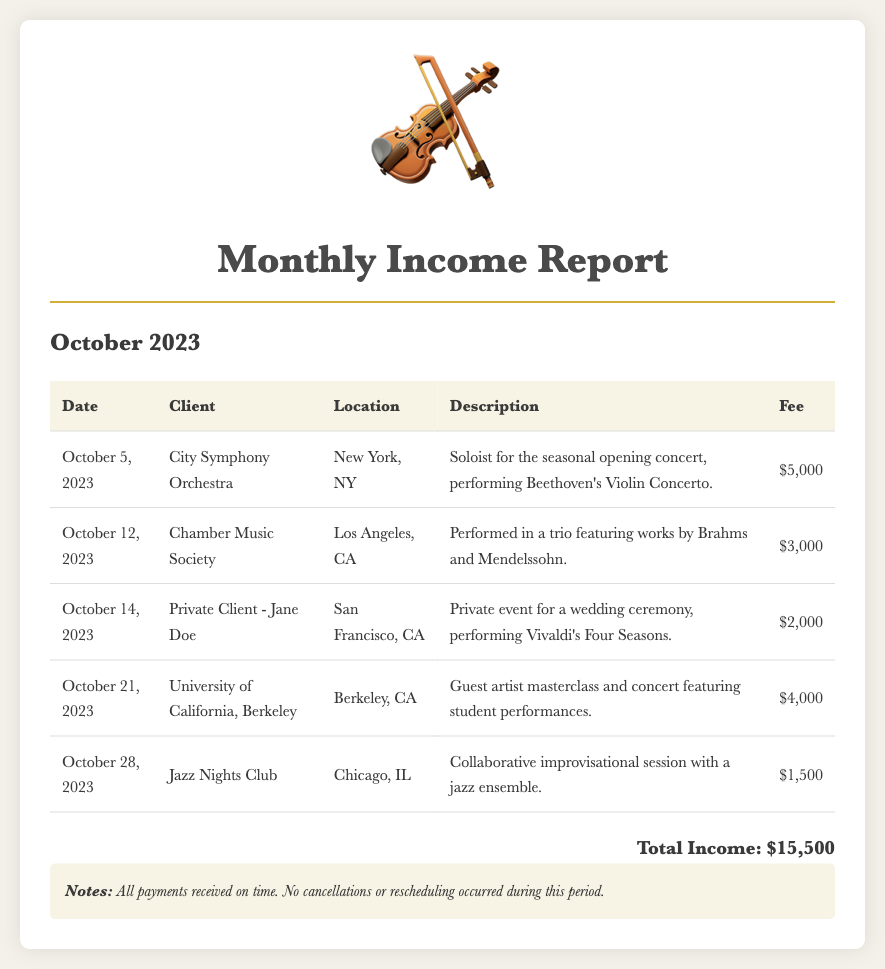What was the total income for October 2023? The total income is explicitly stated in the document as the sum of all fees listed for the month of October, which amounts to $15,500.
Answer: $15,500 Who was the client for the concert on October 5, 2023? The document specifies that the client for the concert on October 5, 2023, was the City Symphony Orchestra.
Answer: City Symphony Orchestra What fee was received for the performance in Chicago? The document details that the fee received for the performance at Jazz Nights Club in Chicago was $1,500.
Answer: $1,500 How many performances were held in California during October 2023? The document includes the performances for two clients located in California in October: a private event in San Francisco and a masterclass at the University of California, Berkeley.
Answer: 2 What type of event was performed for Jane Doe? The description specifies that the event was a private wedding ceremony.
Answer: Private wedding ceremony Which piece was performed at the Chamber Music Society event? The document states that the performance included works by Brahms and Mendelssohn.
Answer: Works by Brahms and Mendelssohn On what date was the collaborative session in Chicago held? The document lists the date of the collaborative improvisational session with a jazz ensemble as October 28, 2023.
Answer: October 28, 2023 What was noted about the payments in the report? The notes indicate that all payments were received on time.
Answer: All payments received on time 